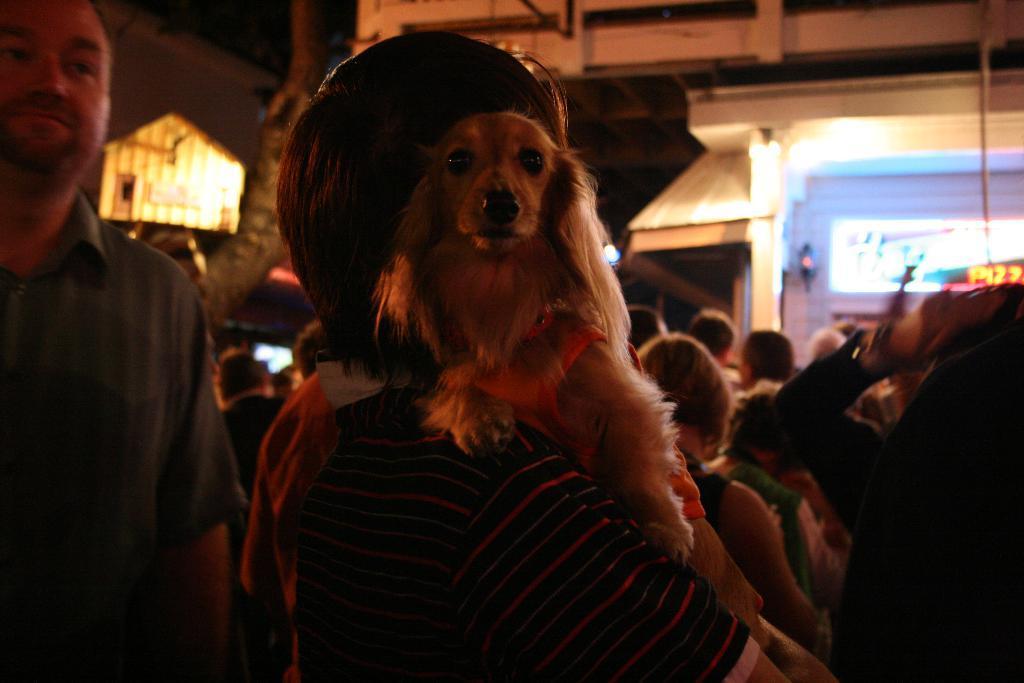How would you summarize this image in a sentence or two? In this picture I can see a group of people are standing. Here I can see a dog is is sitting on a person. In the background I can see buildings. 